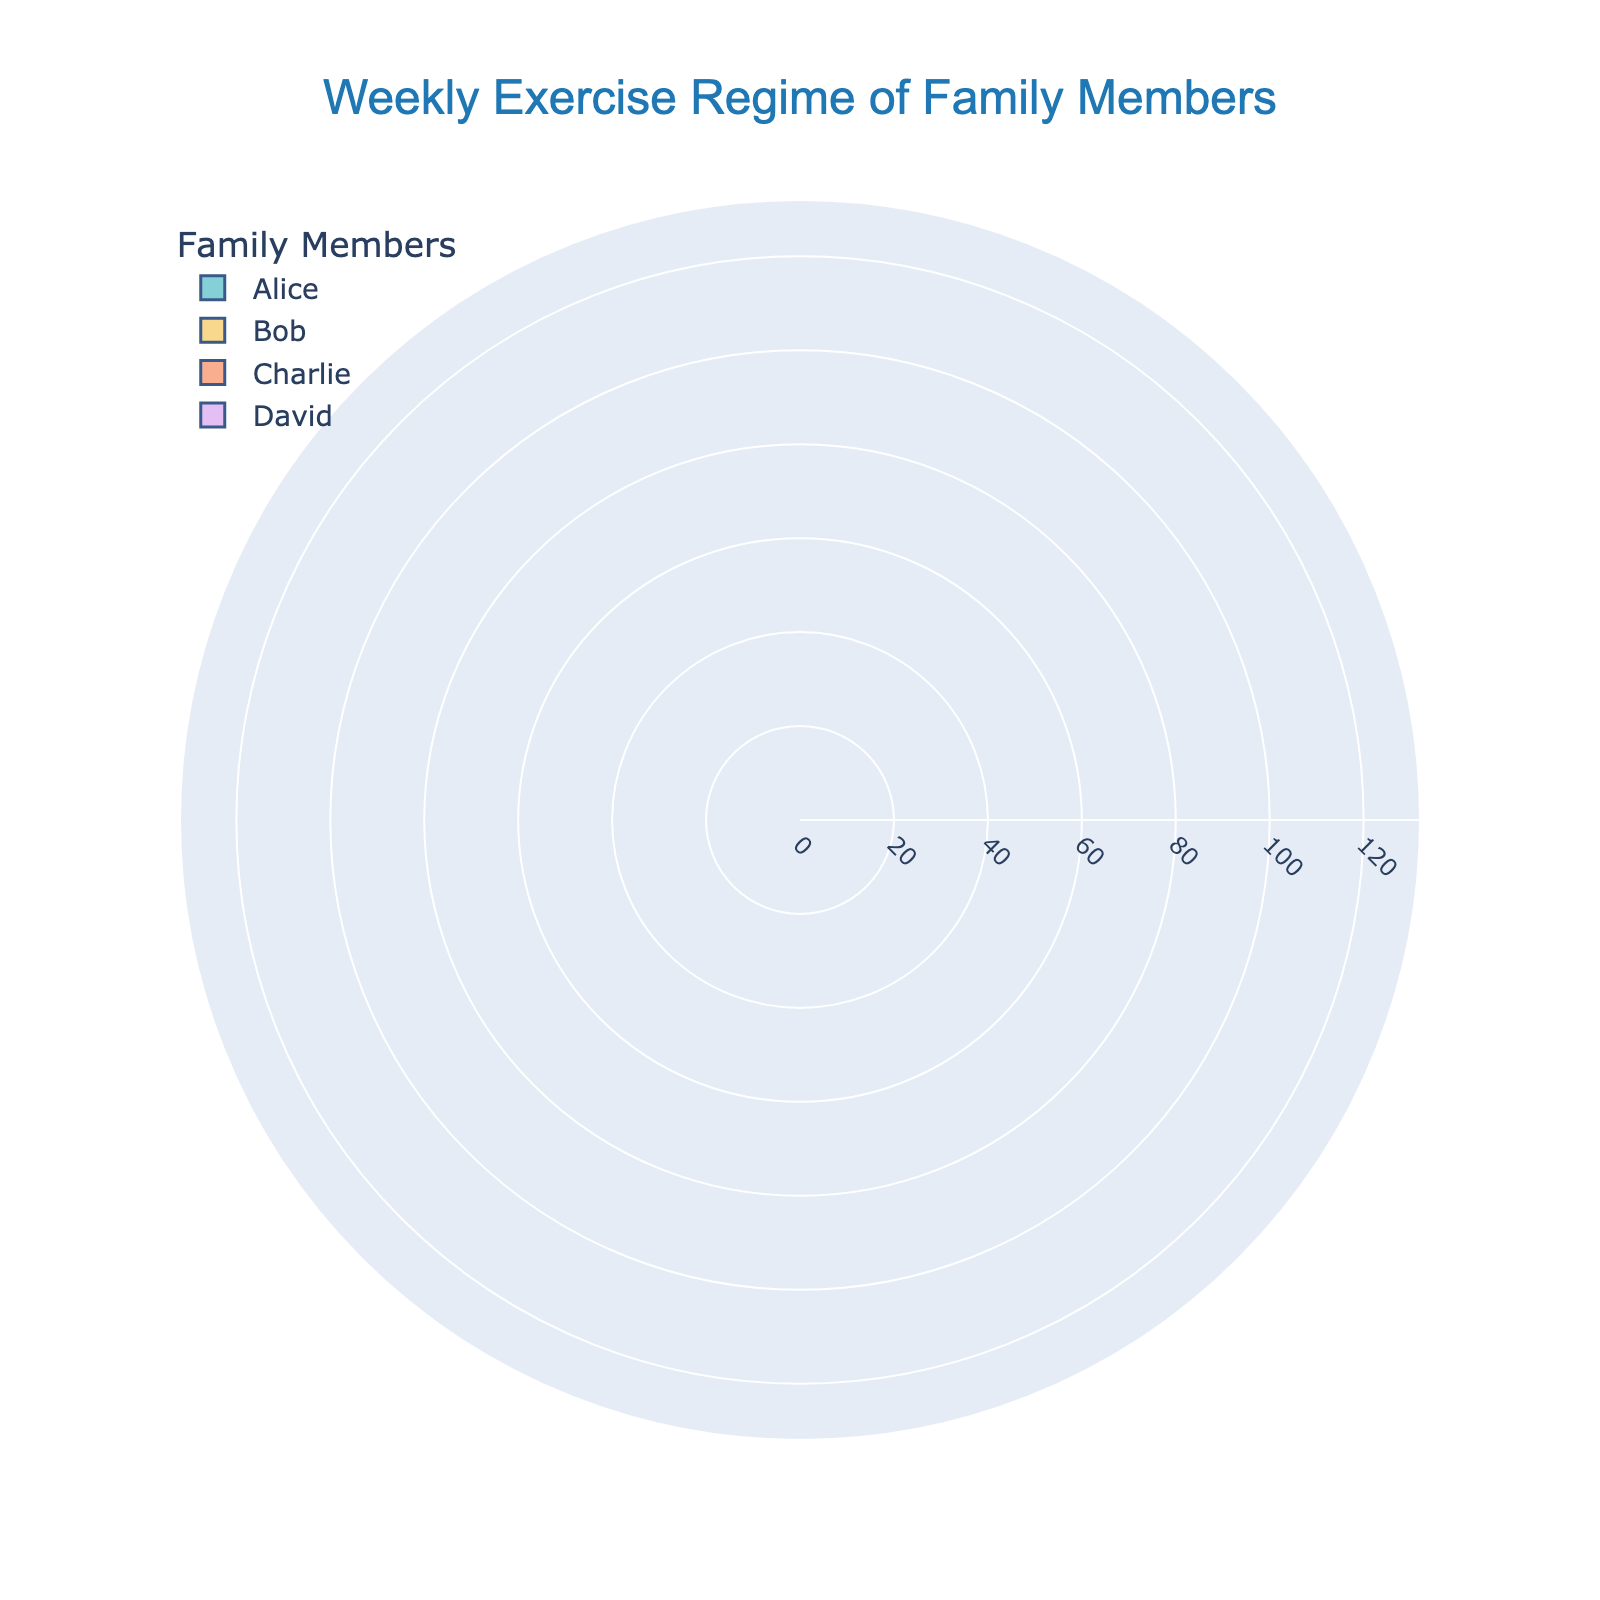What's the title of the chart? The title of the chart is located at the top center and reads "Weekly Exercise Regime of Family Members".
Answer: Weekly Exercise Regime of Family Members Which family member spends the most time running? By examining the lengths of the bars, Bob spends the most time running with 120 minutes per week.
Answer: Bob How many different activities does Alice engage in? Alice has three different bars representing different activities: Running, Yoga, and Strength Training.
Answer: 3 What is the total time Charlie spends on all activities per week? Adding up the minutes from each bar for Charlie: Strength Training (90) + Running (60) + Meditation (30) = 180 minutes.
Answer: 180 minutes Who spends more time on Yoga, Alice or David? By comparing the lengths of the yoga bars, Alice spends 60 minutes while David spends 70 minutes. David spends more time.
Answer: David What's the combined time spent running by Alice, Bob, and David? Sum the time spent running for each: Alice (90 minutes) + Bob (120 minutes) + David (40 minutes) = 250 minutes.
Answer: 250 minutes Which family member has the greatest variety of activities, and how many do they have? Bob participates in three activities: Running, Cycling, and Yoga. No one else participates in more activities.
Answer: Bob, 3 activities How much more time does Charlie spend on Strength Training compared to Alice? Charlie spends 90 minutes on Strength Training, while Alice spends 45 minutes. Difference is 90 - 45 = 45 minutes.
Answer: 45 minutes Who spends the least amount of time running? David spends the least time running with 40 minutes per week.
Answer: David 